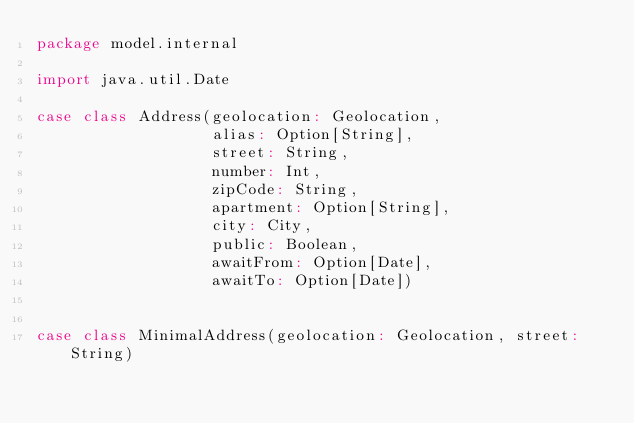<code> <loc_0><loc_0><loc_500><loc_500><_Scala_>package model.internal

import java.util.Date

case class Address(geolocation: Geolocation,
                   alias: Option[String],
                   street: String,
                   number: Int,
                   zipCode: String,
                   apartment: Option[String],
                   city: City,
                   public: Boolean,
                   awaitFrom: Option[Date],
                   awaitTo: Option[Date])


case class MinimalAddress(geolocation: Geolocation, street: String)</code> 